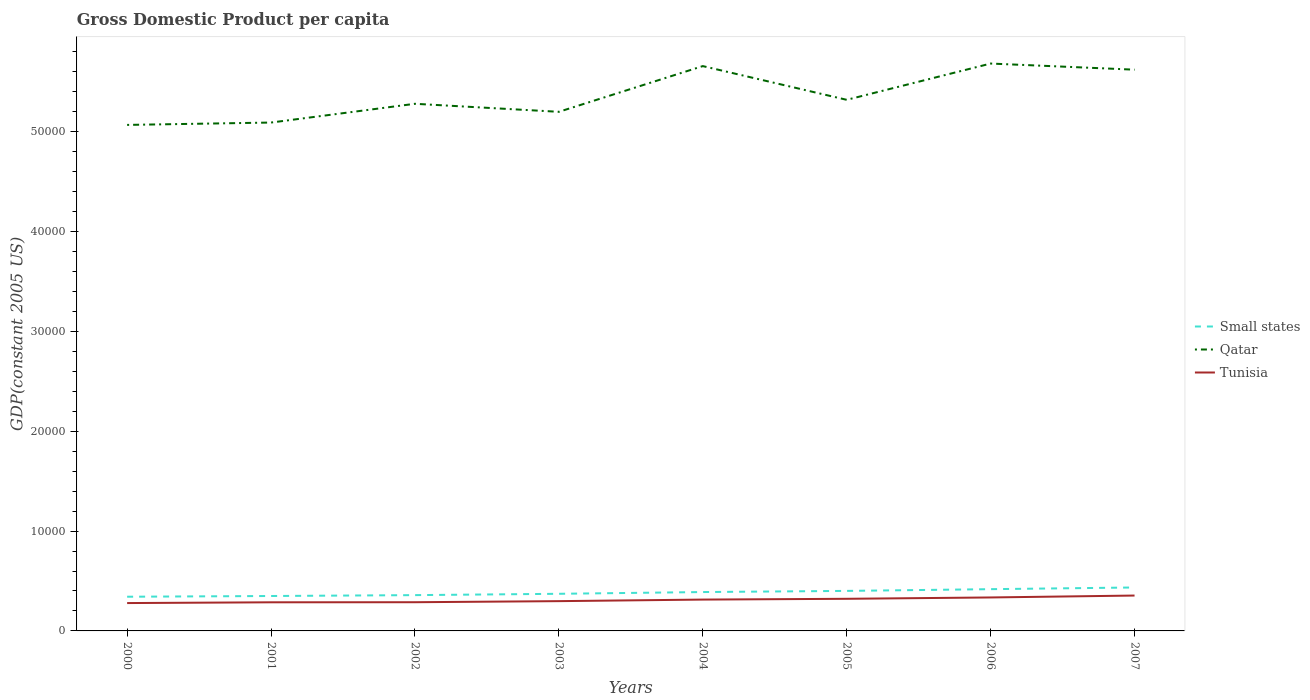Across all years, what is the maximum GDP per capita in Tunisia?
Ensure brevity in your answer.  2790.77. What is the total GDP per capita in Qatar in the graph?
Make the answer very short. -5655.65. What is the difference between the highest and the second highest GDP per capita in Tunisia?
Your answer should be compact. 753.89. How many lines are there?
Provide a succinct answer. 3. What is the difference between two consecutive major ticks on the Y-axis?
Your answer should be very brief. 10000. Are the values on the major ticks of Y-axis written in scientific E-notation?
Your answer should be very brief. No. Does the graph contain any zero values?
Provide a succinct answer. No. Does the graph contain grids?
Offer a very short reply. No. How are the legend labels stacked?
Provide a succinct answer. Vertical. What is the title of the graph?
Your response must be concise. Gross Domestic Product per capita. Does "Timor-Leste" appear as one of the legend labels in the graph?
Make the answer very short. No. What is the label or title of the Y-axis?
Provide a succinct answer. GDP(constant 2005 US). What is the GDP(constant 2005 US) in Small states in 2000?
Keep it short and to the point. 3425.97. What is the GDP(constant 2005 US) of Qatar in 2000?
Your answer should be compact. 5.07e+04. What is the GDP(constant 2005 US) in Tunisia in 2000?
Offer a terse response. 2790.77. What is the GDP(constant 2005 US) in Small states in 2001?
Your answer should be very brief. 3497.99. What is the GDP(constant 2005 US) in Qatar in 2001?
Your response must be concise. 5.09e+04. What is the GDP(constant 2005 US) in Tunisia in 2001?
Your answer should be very brief. 2867.26. What is the GDP(constant 2005 US) of Small states in 2002?
Your answer should be compact. 3586.27. What is the GDP(constant 2005 US) of Qatar in 2002?
Ensure brevity in your answer.  5.28e+04. What is the GDP(constant 2005 US) in Tunisia in 2002?
Your answer should be compact. 2875.89. What is the GDP(constant 2005 US) of Small states in 2003?
Offer a terse response. 3719.38. What is the GDP(constant 2005 US) of Qatar in 2003?
Make the answer very short. 5.20e+04. What is the GDP(constant 2005 US) of Tunisia in 2003?
Your answer should be very brief. 2983.31. What is the GDP(constant 2005 US) in Small states in 2004?
Offer a terse response. 3894.64. What is the GDP(constant 2005 US) of Qatar in 2004?
Offer a very short reply. 5.66e+04. What is the GDP(constant 2005 US) in Tunisia in 2004?
Provide a succinct answer. 3139.8. What is the GDP(constant 2005 US) of Small states in 2005?
Your answer should be very brief. 4009.71. What is the GDP(constant 2005 US) in Qatar in 2005?
Offer a very short reply. 5.32e+04. What is the GDP(constant 2005 US) in Tunisia in 2005?
Offer a terse response. 3217.97. What is the GDP(constant 2005 US) of Small states in 2006?
Offer a very short reply. 4182.88. What is the GDP(constant 2005 US) in Qatar in 2006?
Your response must be concise. 5.68e+04. What is the GDP(constant 2005 US) in Tunisia in 2006?
Give a very brief answer. 3353.65. What is the GDP(constant 2005 US) in Small states in 2007?
Keep it short and to the point. 4352.07. What is the GDP(constant 2005 US) of Qatar in 2007?
Your response must be concise. 5.62e+04. What is the GDP(constant 2005 US) in Tunisia in 2007?
Ensure brevity in your answer.  3544.65. Across all years, what is the maximum GDP(constant 2005 US) in Small states?
Your answer should be compact. 4352.07. Across all years, what is the maximum GDP(constant 2005 US) in Qatar?
Your answer should be compact. 5.68e+04. Across all years, what is the maximum GDP(constant 2005 US) in Tunisia?
Your answer should be very brief. 3544.65. Across all years, what is the minimum GDP(constant 2005 US) in Small states?
Make the answer very short. 3425.97. Across all years, what is the minimum GDP(constant 2005 US) of Qatar?
Provide a short and direct response. 5.07e+04. Across all years, what is the minimum GDP(constant 2005 US) of Tunisia?
Keep it short and to the point. 2790.77. What is the total GDP(constant 2005 US) in Small states in the graph?
Provide a short and direct response. 3.07e+04. What is the total GDP(constant 2005 US) of Qatar in the graph?
Provide a succinct answer. 4.29e+05. What is the total GDP(constant 2005 US) in Tunisia in the graph?
Your response must be concise. 2.48e+04. What is the difference between the GDP(constant 2005 US) in Small states in 2000 and that in 2001?
Offer a very short reply. -72.03. What is the difference between the GDP(constant 2005 US) of Qatar in 2000 and that in 2001?
Make the answer very short. -236.81. What is the difference between the GDP(constant 2005 US) of Tunisia in 2000 and that in 2001?
Provide a succinct answer. -76.5. What is the difference between the GDP(constant 2005 US) of Small states in 2000 and that in 2002?
Your response must be concise. -160.31. What is the difference between the GDP(constant 2005 US) in Qatar in 2000 and that in 2002?
Your response must be concise. -2116.26. What is the difference between the GDP(constant 2005 US) in Tunisia in 2000 and that in 2002?
Make the answer very short. -85.12. What is the difference between the GDP(constant 2005 US) in Small states in 2000 and that in 2003?
Your answer should be compact. -293.42. What is the difference between the GDP(constant 2005 US) in Qatar in 2000 and that in 2003?
Offer a terse response. -1311.81. What is the difference between the GDP(constant 2005 US) of Tunisia in 2000 and that in 2003?
Offer a terse response. -192.54. What is the difference between the GDP(constant 2005 US) of Small states in 2000 and that in 2004?
Make the answer very short. -468.68. What is the difference between the GDP(constant 2005 US) in Qatar in 2000 and that in 2004?
Your response must be concise. -5892.46. What is the difference between the GDP(constant 2005 US) in Tunisia in 2000 and that in 2004?
Provide a short and direct response. -349.03. What is the difference between the GDP(constant 2005 US) in Small states in 2000 and that in 2005?
Make the answer very short. -583.75. What is the difference between the GDP(constant 2005 US) in Qatar in 2000 and that in 2005?
Offer a terse response. -2513.63. What is the difference between the GDP(constant 2005 US) in Tunisia in 2000 and that in 2005?
Offer a terse response. -427.2. What is the difference between the GDP(constant 2005 US) of Small states in 2000 and that in 2006?
Offer a very short reply. -756.92. What is the difference between the GDP(constant 2005 US) in Qatar in 2000 and that in 2006?
Offer a terse response. -6147.15. What is the difference between the GDP(constant 2005 US) of Tunisia in 2000 and that in 2006?
Ensure brevity in your answer.  -562.89. What is the difference between the GDP(constant 2005 US) in Small states in 2000 and that in 2007?
Keep it short and to the point. -926.11. What is the difference between the GDP(constant 2005 US) of Qatar in 2000 and that in 2007?
Ensure brevity in your answer.  -5533.49. What is the difference between the GDP(constant 2005 US) of Tunisia in 2000 and that in 2007?
Offer a terse response. -753.89. What is the difference between the GDP(constant 2005 US) in Small states in 2001 and that in 2002?
Ensure brevity in your answer.  -88.28. What is the difference between the GDP(constant 2005 US) of Qatar in 2001 and that in 2002?
Your answer should be very brief. -1879.45. What is the difference between the GDP(constant 2005 US) of Tunisia in 2001 and that in 2002?
Ensure brevity in your answer.  -8.63. What is the difference between the GDP(constant 2005 US) in Small states in 2001 and that in 2003?
Provide a succinct answer. -221.39. What is the difference between the GDP(constant 2005 US) in Qatar in 2001 and that in 2003?
Ensure brevity in your answer.  -1075. What is the difference between the GDP(constant 2005 US) in Tunisia in 2001 and that in 2003?
Provide a succinct answer. -116.05. What is the difference between the GDP(constant 2005 US) of Small states in 2001 and that in 2004?
Your response must be concise. -396.65. What is the difference between the GDP(constant 2005 US) of Qatar in 2001 and that in 2004?
Your response must be concise. -5655.65. What is the difference between the GDP(constant 2005 US) in Tunisia in 2001 and that in 2004?
Your answer should be compact. -272.53. What is the difference between the GDP(constant 2005 US) of Small states in 2001 and that in 2005?
Your answer should be compact. -511.72. What is the difference between the GDP(constant 2005 US) in Qatar in 2001 and that in 2005?
Keep it short and to the point. -2276.82. What is the difference between the GDP(constant 2005 US) of Tunisia in 2001 and that in 2005?
Ensure brevity in your answer.  -350.71. What is the difference between the GDP(constant 2005 US) of Small states in 2001 and that in 2006?
Provide a succinct answer. -684.89. What is the difference between the GDP(constant 2005 US) in Qatar in 2001 and that in 2006?
Provide a short and direct response. -5910.35. What is the difference between the GDP(constant 2005 US) in Tunisia in 2001 and that in 2006?
Provide a succinct answer. -486.39. What is the difference between the GDP(constant 2005 US) in Small states in 2001 and that in 2007?
Your answer should be compact. -854.08. What is the difference between the GDP(constant 2005 US) of Qatar in 2001 and that in 2007?
Your answer should be very brief. -5296.69. What is the difference between the GDP(constant 2005 US) of Tunisia in 2001 and that in 2007?
Offer a very short reply. -677.39. What is the difference between the GDP(constant 2005 US) of Small states in 2002 and that in 2003?
Keep it short and to the point. -133.11. What is the difference between the GDP(constant 2005 US) of Qatar in 2002 and that in 2003?
Make the answer very short. 804.44. What is the difference between the GDP(constant 2005 US) in Tunisia in 2002 and that in 2003?
Offer a terse response. -107.42. What is the difference between the GDP(constant 2005 US) of Small states in 2002 and that in 2004?
Ensure brevity in your answer.  -308.37. What is the difference between the GDP(constant 2005 US) of Qatar in 2002 and that in 2004?
Your answer should be compact. -3776.21. What is the difference between the GDP(constant 2005 US) in Tunisia in 2002 and that in 2004?
Give a very brief answer. -263.9. What is the difference between the GDP(constant 2005 US) in Small states in 2002 and that in 2005?
Offer a terse response. -423.44. What is the difference between the GDP(constant 2005 US) of Qatar in 2002 and that in 2005?
Your answer should be very brief. -397.37. What is the difference between the GDP(constant 2005 US) of Tunisia in 2002 and that in 2005?
Your answer should be compact. -342.08. What is the difference between the GDP(constant 2005 US) in Small states in 2002 and that in 2006?
Give a very brief answer. -596.61. What is the difference between the GDP(constant 2005 US) of Qatar in 2002 and that in 2006?
Provide a short and direct response. -4030.9. What is the difference between the GDP(constant 2005 US) of Tunisia in 2002 and that in 2006?
Provide a succinct answer. -477.76. What is the difference between the GDP(constant 2005 US) in Small states in 2002 and that in 2007?
Make the answer very short. -765.8. What is the difference between the GDP(constant 2005 US) in Qatar in 2002 and that in 2007?
Your response must be concise. -3417.24. What is the difference between the GDP(constant 2005 US) in Tunisia in 2002 and that in 2007?
Give a very brief answer. -668.76. What is the difference between the GDP(constant 2005 US) of Small states in 2003 and that in 2004?
Ensure brevity in your answer.  -175.26. What is the difference between the GDP(constant 2005 US) of Qatar in 2003 and that in 2004?
Offer a terse response. -4580.65. What is the difference between the GDP(constant 2005 US) of Tunisia in 2003 and that in 2004?
Give a very brief answer. -156.49. What is the difference between the GDP(constant 2005 US) in Small states in 2003 and that in 2005?
Your answer should be compact. -290.33. What is the difference between the GDP(constant 2005 US) of Qatar in 2003 and that in 2005?
Offer a terse response. -1201.82. What is the difference between the GDP(constant 2005 US) of Tunisia in 2003 and that in 2005?
Keep it short and to the point. -234.66. What is the difference between the GDP(constant 2005 US) of Small states in 2003 and that in 2006?
Give a very brief answer. -463.5. What is the difference between the GDP(constant 2005 US) in Qatar in 2003 and that in 2006?
Your answer should be compact. -4835.34. What is the difference between the GDP(constant 2005 US) in Tunisia in 2003 and that in 2006?
Ensure brevity in your answer.  -370.34. What is the difference between the GDP(constant 2005 US) in Small states in 2003 and that in 2007?
Your answer should be compact. -632.69. What is the difference between the GDP(constant 2005 US) in Qatar in 2003 and that in 2007?
Ensure brevity in your answer.  -4221.68. What is the difference between the GDP(constant 2005 US) in Tunisia in 2003 and that in 2007?
Offer a very short reply. -561.34. What is the difference between the GDP(constant 2005 US) of Small states in 2004 and that in 2005?
Offer a very short reply. -115.07. What is the difference between the GDP(constant 2005 US) of Qatar in 2004 and that in 2005?
Provide a short and direct response. 3378.83. What is the difference between the GDP(constant 2005 US) in Tunisia in 2004 and that in 2005?
Offer a very short reply. -78.17. What is the difference between the GDP(constant 2005 US) of Small states in 2004 and that in 2006?
Your answer should be very brief. -288.24. What is the difference between the GDP(constant 2005 US) in Qatar in 2004 and that in 2006?
Offer a very short reply. -254.69. What is the difference between the GDP(constant 2005 US) of Tunisia in 2004 and that in 2006?
Your answer should be compact. -213.86. What is the difference between the GDP(constant 2005 US) in Small states in 2004 and that in 2007?
Your response must be concise. -457.43. What is the difference between the GDP(constant 2005 US) in Qatar in 2004 and that in 2007?
Keep it short and to the point. 358.97. What is the difference between the GDP(constant 2005 US) in Tunisia in 2004 and that in 2007?
Give a very brief answer. -404.86. What is the difference between the GDP(constant 2005 US) of Small states in 2005 and that in 2006?
Make the answer very short. -173.17. What is the difference between the GDP(constant 2005 US) of Qatar in 2005 and that in 2006?
Keep it short and to the point. -3633.53. What is the difference between the GDP(constant 2005 US) in Tunisia in 2005 and that in 2006?
Make the answer very short. -135.68. What is the difference between the GDP(constant 2005 US) in Small states in 2005 and that in 2007?
Your answer should be very brief. -342.36. What is the difference between the GDP(constant 2005 US) in Qatar in 2005 and that in 2007?
Keep it short and to the point. -3019.87. What is the difference between the GDP(constant 2005 US) of Tunisia in 2005 and that in 2007?
Your answer should be compact. -326.68. What is the difference between the GDP(constant 2005 US) in Small states in 2006 and that in 2007?
Offer a terse response. -169.19. What is the difference between the GDP(constant 2005 US) of Qatar in 2006 and that in 2007?
Your answer should be very brief. 613.66. What is the difference between the GDP(constant 2005 US) in Tunisia in 2006 and that in 2007?
Provide a short and direct response. -191. What is the difference between the GDP(constant 2005 US) of Small states in 2000 and the GDP(constant 2005 US) of Qatar in 2001?
Give a very brief answer. -4.75e+04. What is the difference between the GDP(constant 2005 US) in Small states in 2000 and the GDP(constant 2005 US) in Tunisia in 2001?
Give a very brief answer. 558.7. What is the difference between the GDP(constant 2005 US) of Qatar in 2000 and the GDP(constant 2005 US) of Tunisia in 2001?
Ensure brevity in your answer.  4.78e+04. What is the difference between the GDP(constant 2005 US) in Small states in 2000 and the GDP(constant 2005 US) in Qatar in 2002?
Offer a terse response. -4.94e+04. What is the difference between the GDP(constant 2005 US) of Small states in 2000 and the GDP(constant 2005 US) of Tunisia in 2002?
Make the answer very short. 550.07. What is the difference between the GDP(constant 2005 US) of Qatar in 2000 and the GDP(constant 2005 US) of Tunisia in 2002?
Your answer should be compact. 4.78e+04. What is the difference between the GDP(constant 2005 US) of Small states in 2000 and the GDP(constant 2005 US) of Qatar in 2003?
Your answer should be very brief. -4.86e+04. What is the difference between the GDP(constant 2005 US) in Small states in 2000 and the GDP(constant 2005 US) in Tunisia in 2003?
Ensure brevity in your answer.  442.65. What is the difference between the GDP(constant 2005 US) of Qatar in 2000 and the GDP(constant 2005 US) of Tunisia in 2003?
Make the answer very short. 4.77e+04. What is the difference between the GDP(constant 2005 US) of Small states in 2000 and the GDP(constant 2005 US) of Qatar in 2004?
Offer a terse response. -5.32e+04. What is the difference between the GDP(constant 2005 US) of Small states in 2000 and the GDP(constant 2005 US) of Tunisia in 2004?
Your answer should be very brief. 286.17. What is the difference between the GDP(constant 2005 US) in Qatar in 2000 and the GDP(constant 2005 US) in Tunisia in 2004?
Offer a very short reply. 4.76e+04. What is the difference between the GDP(constant 2005 US) of Small states in 2000 and the GDP(constant 2005 US) of Qatar in 2005?
Offer a terse response. -4.98e+04. What is the difference between the GDP(constant 2005 US) in Small states in 2000 and the GDP(constant 2005 US) in Tunisia in 2005?
Provide a succinct answer. 208. What is the difference between the GDP(constant 2005 US) in Qatar in 2000 and the GDP(constant 2005 US) in Tunisia in 2005?
Keep it short and to the point. 4.75e+04. What is the difference between the GDP(constant 2005 US) in Small states in 2000 and the GDP(constant 2005 US) in Qatar in 2006?
Your answer should be compact. -5.34e+04. What is the difference between the GDP(constant 2005 US) of Small states in 2000 and the GDP(constant 2005 US) of Tunisia in 2006?
Provide a succinct answer. 72.31. What is the difference between the GDP(constant 2005 US) of Qatar in 2000 and the GDP(constant 2005 US) of Tunisia in 2006?
Your answer should be compact. 4.73e+04. What is the difference between the GDP(constant 2005 US) in Small states in 2000 and the GDP(constant 2005 US) in Qatar in 2007?
Ensure brevity in your answer.  -5.28e+04. What is the difference between the GDP(constant 2005 US) in Small states in 2000 and the GDP(constant 2005 US) in Tunisia in 2007?
Your answer should be very brief. -118.69. What is the difference between the GDP(constant 2005 US) in Qatar in 2000 and the GDP(constant 2005 US) in Tunisia in 2007?
Provide a short and direct response. 4.71e+04. What is the difference between the GDP(constant 2005 US) in Small states in 2001 and the GDP(constant 2005 US) in Qatar in 2002?
Offer a terse response. -4.93e+04. What is the difference between the GDP(constant 2005 US) in Small states in 2001 and the GDP(constant 2005 US) in Tunisia in 2002?
Offer a very short reply. 622.1. What is the difference between the GDP(constant 2005 US) of Qatar in 2001 and the GDP(constant 2005 US) of Tunisia in 2002?
Ensure brevity in your answer.  4.81e+04. What is the difference between the GDP(constant 2005 US) in Small states in 2001 and the GDP(constant 2005 US) in Qatar in 2003?
Provide a succinct answer. -4.85e+04. What is the difference between the GDP(constant 2005 US) in Small states in 2001 and the GDP(constant 2005 US) in Tunisia in 2003?
Make the answer very short. 514.68. What is the difference between the GDP(constant 2005 US) in Qatar in 2001 and the GDP(constant 2005 US) in Tunisia in 2003?
Offer a very short reply. 4.79e+04. What is the difference between the GDP(constant 2005 US) of Small states in 2001 and the GDP(constant 2005 US) of Qatar in 2004?
Give a very brief answer. -5.31e+04. What is the difference between the GDP(constant 2005 US) in Small states in 2001 and the GDP(constant 2005 US) in Tunisia in 2004?
Keep it short and to the point. 358.2. What is the difference between the GDP(constant 2005 US) in Qatar in 2001 and the GDP(constant 2005 US) in Tunisia in 2004?
Offer a very short reply. 4.78e+04. What is the difference between the GDP(constant 2005 US) in Small states in 2001 and the GDP(constant 2005 US) in Qatar in 2005?
Ensure brevity in your answer.  -4.97e+04. What is the difference between the GDP(constant 2005 US) of Small states in 2001 and the GDP(constant 2005 US) of Tunisia in 2005?
Make the answer very short. 280.03. What is the difference between the GDP(constant 2005 US) in Qatar in 2001 and the GDP(constant 2005 US) in Tunisia in 2005?
Make the answer very short. 4.77e+04. What is the difference between the GDP(constant 2005 US) of Small states in 2001 and the GDP(constant 2005 US) of Qatar in 2006?
Your response must be concise. -5.33e+04. What is the difference between the GDP(constant 2005 US) in Small states in 2001 and the GDP(constant 2005 US) in Tunisia in 2006?
Provide a succinct answer. 144.34. What is the difference between the GDP(constant 2005 US) in Qatar in 2001 and the GDP(constant 2005 US) in Tunisia in 2006?
Your answer should be very brief. 4.76e+04. What is the difference between the GDP(constant 2005 US) in Small states in 2001 and the GDP(constant 2005 US) in Qatar in 2007?
Offer a terse response. -5.27e+04. What is the difference between the GDP(constant 2005 US) of Small states in 2001 and the GDP(constant 2005 US) of Tunisia in 2007?
Your answer should be compact. -46.66. What is the difference between the GDP(constant 2005 US) in Qatar in 2001 and the GDP(constant 2005 US) in Tunisia in 2007?
Your answer should be compact. 4.74e+04. What is the difference between the GDP(constant 2005 US) of Small states in 2002 and the GDP(constant 2005 US) of Qatar in 2003?
Your response must be concise. -4.84e+04. What is the difference between the GDP(constant 2005 US) in Small states in 2002 and the GDP(constant 2005 US) in Tunisia in 2003?
Make the answer very short. 602.96. What is the difference between the GDP(constant 2005 US) in Qatar in 2002 and the GDP(constant 2005 US) in Tunisia in 2003?
Your answer should be very brief. 4.98e+04. What is the difference between the GDP(constant 2005 US) of Small states in 2002 and the GDP(constant 2005 US) of Qatar in 2004?
Provide a succinct answer. -5.30e+04. What is the difference between the GDP(constant 2005 US) of Small states in 2002 and the GDP(constant 2005 US) of Tunisia in 2004?
Make the answer very short. 446.48. What is the difference between the GDP(constant 2005 US) in Qatar in 2002 and the GDP(constant 2005 US) in Tunisia in 2004?
Provide a succinct answer. 4.97e+04. What is the difference between the GDP(constant 2005 US) of Small states in 2002 and the GDP(constant 2005 US) of Qatar in 2005?
Provide a succinct answer. -4.96e+04. What is the difference between the GDP(constant 2005 US) in Small states in 2002 and the GDP(constant 2005 US) in Tunisia in 2005?
Your answer should be compact. 368.3. What is the difference between the GDP(constant 2005 US) in Qatar in 2002 and the GDP(constant 2005 US) in Tunisia in 2005?
Your response must be concise. 4.96e+04. What is the difference between the GDP(constant 2005 US) in Small states in 2002 and the GDP(constant 2005 US) in Qatar in 2006?
Give a very brief answer. -5.33e+04. What is the difference between the GDP(constant 2005 US) of Small states in 2002 and the GDP(constant 2005 US) of Tunisia in 2006?
Your response must be concise. 232.62. What is the difference between the GDP(constant 2005 US) in Qatar in 2002 and the GDP(constant 2005 US) in Tunisia in 2006?
Your response must be concise. 4.95e+04. What is the difference between the GDP(constant 2005 US) of Small states in 2002 and the GDP(constant 2005 US) of Qatar in 2007?
Ensure brevity in your answer.  -5.26e+04. What is the difference between the GDP(constant 2005 US) in Small states in 2002 and the GDP(constant 2005 US) in Tunisia in 2007?
Keep it short and to the point. 41.62. What is the difference between the GDP(constant 2005 US) in Qatar in 2002 and the GDP(constant 2005 US) in Tunisia in 2007?
Provide a succinct answer. 4.93e+04. What is the difference between the GDP(constant 2005 US) in Small states in 2003 and the GDP(constant 2005 US) in Qatar in 2004?
Your answer should be very brief. -5.29e+04. What is the difference between the GDP(constant 2005 US) in Small states in 2003 and the GDP(constant 2005 US) in Tunisia in 2004?
Give a very brief answer. 579.59. What is the difference between the GDP(constant 2005 US) of Qatar in 2003 and the GDP(constant 2005 US) of Tunisia in 2004?
Your answer should be compact. 4.89e+04. What is the difference between the GDP(constant 2005 US) of Small states in 2003 and the GDP(constant 2005 US) of Qatar in 2005?
Ensure brevity in your answer.  -4.95e+04. What is the difference between the GDP(constant 2005 US) in Small states in 2003 and the GDP(constant 2005 US) in Tunisia in 2005?
Make the answer very short. 501.41. What is the difference between the GDP(constant 2005 US) in Qatar in 2003 and the GDP(constant 2005 US) in Tunisia in 2005?
Make the answer very short. 4.88e+04. What is the difference between the GDP(constant 2005 US) of Small states in 2003 and the GDP(constant 2005 US) of Qatar in 2006?
Your response must be concise. -5.31e+04. What is the difference between the GDP(constant 2005 US) of Small states in 2003 and the GDP(constant 2005 US) of Tunisia in 2006?
Your answer should be very brief. 365.73. What is the difference between the GDP(constant 2005 US) of Qatar in 2003 and the GDP(constant 2005 US) of Tunisia in 2006?
Your answer should be very brief. 4.87e+04. What is the difference between the GDP(constant 2005 US) of Small states in 2003 and the GDP(constant 2005 US) of Qatar in 2007?
Make the answer very short. -5.25e+04. What is the difference between the GDP(constant 2005 US) in Small states in 2003 and the GDP(constant 2005 US) in Tunisia in 2007?
Provide a short and direct response. 174.73. What is the difference between the GDP(constant 2005 US) of Qatar in 2003 and the GDP(constant 2005 US) of Tunisia in 2007?
Your response must be concise. 4.85e+04. What is the difference between the GDP(constant 2005 US) in Small states in 2004 and the GDP(constant 2005 US) in Qatar in 2005?
Your answer should be compact. -4.93e+04. What is the difference between the GDP(constant 2005 US) in Small states in 2004 and the GDP(constant 2005 US) in Tunisia in 2005?
Make the answer very short. 676.68. What is the difference between the GDP(constant 2005 US) of Qatar in 2004 and the GDP(constant 2005 US) of Tunisia in 2005?
Make the answer very short. 5.34e+04. What is the difference between the GDP(constant 2005 US) in Small states in 2004 and the GDP(constant 2005 US) in Qatar in 2006?
Make the answer very short. -5.29e+04. What is the difference between the GDP(constant 2005 US) of Small states in 2004 and the GDP(constant 2005 US) of Tunisia in 2006?
Give a very brief answer. 540.99. What is the difference between the GDP(constant 2005 US) in Qatar in 2004 and the GDP(constant 2005 US) in Tunisia in 2006?
Make the answer very short. 5.32e+04. What is the difference between the GDP(constant 2005 US) of Small states in 2004 and the GDP(constant 2005 US) of Qatar in 2007?
Offer a terse response. -5.23e+04. What is the difference between the GDP(constant 2005 US) in Small states in 2004 and the GDP(constant 2005 US) in Tunisia in 2007?
Offer a very short reply. 349.99. What is the difference between the GDP(constant 2005 US) of Qatar in 2004 and the GDP(constant 2005 US) of Tunisia in 2007?
Your answer should be very brief. 5.30e+04. What is the difference between the GDP(constant 2005 US) in Small states in 2005 and the GDP(constant 2005 US) in Qatar in 2006?
Make the answer very short. -5.28e+04. What is the difference between the GDP(constant 2005 US) in Small states in 2005 and the GDP(constant 2005 US) in Tunisia in 2006?
Provide a short and direct response. 656.06. What is the difference between the GDP(constant 2005 US) of Qatar in 2005 and the GDP(constant 2005 US) of Tunisia in 2006?
Provide a succinct answer. 4.99e+04. What is the difference between the GDP(constant 2005 US) in Small states in 2005 and the GDP(constant 2005 US) in Qatar in 2007?
Provide a succinct answer. -5.22e+04. What is the difference between the GDP(constant 2005 US) of Small states in 2005 and the GDP(constant 2005 US) of Tunisia in 2007?
Give a very brief answer. 465.06. What is the difference between the GDP(constant 2005 US) in Qatar in 2005 and the GDP(constant 2005 US) in Tunisia in 2007?
Give a very brief answer. 4.97e+04. What is the difference between the GDP(constant 2005 US) in Small states in 2006 and the GDP(constant 2005 US) in Qatar in 2007?
Give a very brief answer. -5.20e+04. What is the difference between the GDP(constant 2005 US) of Small states in 2006 and the GDP(constant 2005 US) of Tunisia in 2007?
Give a very brief answer. 638.23. What is the difference between the GDP(constant 2005 US) of Qatar in 2006 and the GDP(constant 2005 US) of Tunisia in 2007?
Keep it short and to the point. 5.33e+04. What is the average GDP(constant 2005 US) of Small states per year?
Offer a very short reply. 3833.62. What is the average GDP(constant 2005 US) in Qatar per year?
Make the answer very short. 5.37e+04. What is the average GDP(constant 2005 US) of Tunisia per year?
Make the answer very short. 3096.66. In the year 2000, what is the difference between the GDP(constant 2005 US) of Small states and GDP(constant 2005 US) of Qatar?
Offer a terse response. -4.73e+04. In the year 2000, what is the difference between the GDP(constant 2005 US) in Small states and GDP(constant 2005 US) in Tunisia?
Provide a short and direct response. 635.2. In the year 2000, what is the difference between the GDP(constant 2005 US) in Qatar and GDP(constant 2005 US) in Tunisia?
Give a very brief answer. 4.79e+04. In the year 2001, what is the difference between the GDP(constant 2005 US) in Small states and GDP(constant 2005 US) in Qatar?
Your answer should be very brief. -4.74e+04. In the year 2001, what is the difference between the GDP(constant 2005 US) of Small states and GDP(constant 2005 US) of Tunisia?
Offer a terse response. 630.73. In the year 2001, what is the difference between the GDP(constant 2005 US) of Qatar and GDP(constant 2005 US) of Tunisia?
Your response must be concise. 4.81e+04. In the year 2002, what is the difference between the GDP(constant 2005 US) in Small states and GDP(constant 2005 US) in Qatar?
Give a very brief answer. -4.92e+04. In the year 2002, what is the difference between the GDP(constant 2005 US) of Small states and GDP(constant 2005 US) of Tunisia?
Offer a terse response. 710.38. In the year 2002, what is the difference between the GDP(constant 2005 US) in Qatar and GDP(constant 2005 US) in Tunisia?
Your response must be concise. 4.99e+04. In the year 2003, what is the difference between the GDP(constant 2005 US) of Small states and GDP(constant 2005 US) of Qatar?
Your answer should be compact. -4.83e+04. In the year 2003, what is the difference between the GDP(constant 2005 US) of Small states and GDP(constant 2005 US) of Tunisia?
Ensure brevity in your answer.  736.07. In the year 2003, what is the difference between the GDP(constant 2005 US) of Qatar and GDP(constant 2005 US) of Tunisia?
Offer a very short reply. 4.90e+04. In the year 2004, what is the difference between the GDP(constant 2005 US) in Small states and GDP(constant 2005 US) in Qatar?
Offer a very short reply. -5.27e+04. In the year 2004, what is the difference between the GDP(constant 2005 US) in Small states and GDP(constant 2005 US) in Tunisia?
Offer a very short reply. 754.85. In the year 2004, what is the difference between the GDP(constant 2005 US) of Qatar and GDP(constant 2005 US) of Tunisia?
Provide a short and direct response. 5.34e+04. In the year 2005, what is the difference between the GDP(constant 2005 US) of Small states and GDP(constant 2005 US) of Qatar?
Provide a succinct answer. -4.92e+04. In the year 2005, what is the difference between the GDP(constant 2005 US) of Small states and GDP(constant 2005 US) of Tunisia?
Offer a very short reply. 791.75. In the year 2005, what is the difference between the GDP(constant 2005 US) of Qatar and GDP(constant 2005 US) of Tunisia?
Offer a terse response. 5.00e+04. In the year 2006, what is the difference between the GDP(constant 2005 US) in Small states and GDP(constant 2005 US) in Qatar?
Ensure brevity in your answer.  -5.27e+04. In the year 2006, what is the difference between the GDP(constant 2005 US) in Small states and GDP(constant 2005 US) in Tunisia?
Give a very brief answer. 829.23. In the year 2006, what is the difference between the GDP(constant 2005 US) of Qatar and GDP(constant 2005 US) of Tunisia?
Your response must be concise. 5.35e+04. In the year 2007, what is the difference between the GDP(constant 2005 US) of Small states and GDP(constant 2005 US) of Qatar?
Provide a short and direct response. -5.19e+04. In the year 2007, what is the difference between the GDP(constant 2005 US) of Small states and GDP(constant 2005 US) of Tunisia?
Make the answer very short. 807.42. In the year 2007, what is the difference between the GDP(constant 2005 US) in Qatar and GDP(constant 2005 US) in Tunisia?
Keep it short and to the point. 5.27e+04. What is the ratio of the GDP(constant 2005 US) in Small states in 2000 to that in 2001?
Provide a short and direct response. 0.98. What is the ratio of the GDP(constant 2005 US) of Tunisia in 2000 to that in 2001?
Give a very brief answer. 0.97. What is the ratio of the GDP(constant 2005 US) in Small states in 2000 to that in 2002?
Provide a succinct answer. 0.96. What is the ratio of the GDP(constant 2005 US) of Qatar in 2000 to that in 2002?
Keep it short and to the point. 0.96. What is the ratio of the GDP(constant 2005 US) in Tunisia in 2000 to that in 2002?
Your response must be concise. 0.97. What is the ratio of the GDP(constant 2005 US) in Small states in 2000 to that in 2003?
Offer a terse response. 0.92. What is the ratio of the GDP(constant 2005 US) in Qatar in 2000 to that in 2003?
Give a very brief answer. 0.97. What is the ratio of the GDP(constant 2005 US) of Tunisia in 2000 to that in 2003?
Your response must be concise. 0.94. What is the ratio of the GDP(constant 2005 US) in Small states in 2000 to that in 2004?
Offer a very short reply. 0.88. What is the ratio of the GDP(constant 2005 US) in Qatar in 2000 to that in 2004?
Your answer should be compact. 0.9. What is the ratio of the GDP(constant 2005 US) in Tunisia in 2000 to that in 2004?
Offer a terse response. 0.89. What is the ratio of the GDP(constant 2005 US) in Small states in 2000 to that in 2005?
Your answer should be compact. 0.85. What is the ratio of the GDP(constant 2005 US) of Qatar in 2000 to that in 2005?
Keep it short and to the point. 0.95. What is the ratio of the GDP(constant 2005 US) of Tunisia in 2000 to that in 2005?
Make the answer very short. 0.87. What is the ratio of the GDP(constant 2005 US) in Small states in 2000 to that in 2006?
Ensure brevity in your answer.  0.82. What is the ratio of the GDP(constant 2005 US) in Qatar in 2000 to that in 2006?
Ensure brevity in your answer.  0.89. What is the ratio of the GDP(constant 2005 US) in Tunisia in 2000 to that in 2006?
Ensure brevity in your answer.  0.83. What is the ratio of the GDP(constant 2005 US) in Small states in 2000 to that in 2007?
Offer a terse response. 0.79. What is the ratio of the GDP(constant 2005 US) of Qatar in 2000 to that in 2007?
Keep it short and to the point. 0.9. What is the ratio of the GDP(constant 2005 US) of Tunisia in 2000 to that in 2007?
Keep it short and to the point. 0.79. What is the ratio of the GDP(constant 2005 US) in Small states in 2001 to that in 2002?
Give a very brief answer. 0.98. What is the ratio of the GDP(constant 2005 US) of Qatar in 2001 to that in 2002?
Keep it short and to the point. 0.96. What is the ratio of the GDP(constant 2005 US) in Small states in 2001 to that in 2003?
Your response must be concise. 0.94. What is the ratio of the GDP(constant 2005 US) in Qatar in 2001 to that in 2003?
Your response must be concise. 0.98. What is the ratio of the GDP(constant 2005 US) of Tunisia in 2001 to that in 2003?
Offer a very short reply. 0.96. What is the ratio of the GDP(constant 2005 US) of Small states in 2001 to that in 2004?
Keep it short and to the point. 0.9. What is the ratio of the GDP(constant 2005 US) in Qatar in 2001 to that in 2004?
Offer a terse response. 0.9. What is the ratio of the GDP(constant 2005 US) of Tunisia in 2001 to that in 2004?
Give a very brief answer. 0.91. What is the ratio of the GDP(constant 2005 US) of Small states in 2001 to that in 2005?
Provide a short and direct response. 0.87. What is the ratio of the GDP(constant 2005 US) in Qatar in 2001 to that in 2005?
Offer a terse response. 0.96. What is the ratio of the GDP(constant 2005 US) in Tunisia in 2001 to that in 2005?
Ensure brevity in your answer.  0.89. What is the ratio of the GDP(constant 2005 US) in Small states in 2001 to that in 2006?
Provide a succinct answer. 0.84. What is the ratio of the GDP(constant 2005 US) of Qatar in 2001 to that in 2006?
Keep it short and to the point. 0.9. What is the ratio of the GDP(constant 2005 US) in Tunisia in 2001 to that in 2006?
Provide a succinct answer. 0.85. What is the ratio of the GDP(constant 2005 US) of Small states in 2001 to that in 2007?
Give a very brief answer. 0.8. What is the ratio of the GDP(constant 2005 US) in Qatar in 2001 to that in 2007?
Ensure brevity in your answer.  0.91. What is the ratio of the GDP(constant 2005 US) of Tunisia in 2001 to that in 2007?
Your answer should be compact. 0.81. What is the ratio of the GDP(constant 2005 US) of Small states in 2002 to that in 2003?
Offer a terse response. 0.96. What is the ratio of the GDP(constant 2005 US) of Qatar in 2002 to that in 2003?
Offer a terse response. 1.02. What is the ratio of the GDP(constant 2005 US) of Small states in 2002 to that in 2004?
Provide a short and direct response. 0.92. What is the ratio of the GDP(constant 2005 US) of Tunisia in 2002 to that in 2004?
Offer a very short reply. 0.92. What is the ratio of the GDP(constant 2005 US) of Small states in 2002 to that in 2005?
Ensure brevity in your answer.  0.89. What is the ratio of the GDP(constant 2005 US) in Qatar in 2002 to that in 2005?
Provide a succinct answer. 0.99. What is the ratio of the GDP(constant 2005 US) of Tunisia in 2002 to that in 2005?
Ensure brevity in your answer.  0.89. What is the ratio of the GDP(constant 2005 US) of Small states in 2002 to that in 2006?
Offer a very short reply. 0.86. What is the ratio of the GDP(constant 2005 US) of Qatar in 2002 to that in 2006?
Offer a terse response. 0.93. What is the ratio of the GDP(constant 2005 US) in Tunisia in 2002 to that in 2006?
Make the answer very short. 0.86. What is the ratio of the GDP(constant 2005 US) in Small states in 2002 to that in 2007?
Make the answer very short. 0.82. What is the ratio of the GDP(constant 2005 US) of Qatar in 2002 to that in 2007?
Provide a short and direct response. 0.94. What is the ratio of the GDP(constant 2005 US) of Tunisia in 2002 to that in 2007?
Offer a terse response. 0.81. What is the ratio of the GDP(constant 2005 US) of Small states in 2003 to that in 2004?
Your answer should be compact. 0.95. What is the ratio of the GDP(constant 2005 US) of Qatar in 2003 to that in 2004?
Ensure brevity in your answer.  0.92. What is the ratio of the GDP(constant 2005 US) in Tunisia in 2003 to that in 2004?
Offer a very short reply. 0.95. What is the ratio of the GDP(constant 2005 US) of Small states in 2003 to that in 2005?
Provide a succinct answer. 0.93. What is the ratio of the GDP(constant 2005 US) in Qatar in 2003 to that in 2005?
Your answer should be very brief. 0.98. What is the ratio of the GDP(constant 2005 US) of Tunisia in 2003 to that in 2005?
Your answer should be very brief. 0.93. What is the ratio of the GDP(constant 2005 US) of Small states in 2003 to that in 2006?
Provide a succinct answer. 0.89. What is the ratio of the GDP(constant 2005 US) of Qatar in 2003 to that in 2006?
Make the answer very short. 0.91. What is the ratio of the GDP(constant 2005 US) of Tunisia in 2003 to that in 2006?
Ensure brevity in your answer.  0.89. What is the ratio of the GDP(constant 2005 US) in Small states in 2003 to that in 2007?
Your answer should be compact. 0.85. What is the ratio of the GDP(constant 2005 US) in Qatar in 2003 to that in 2007?
Your response must be concise. 0.92. What is the ratio of the GDP(constant 2005 US) of Tunisia in 2003 to that in 2007?
Offer a terse response. 0.84. What is the ratio of the GDP(constant 2005 US) of Small states in 2004 to that in 2005?
Provide a short and direct response. 0.97. What is the ratio of the GDP(constant 2005 US) in Qatar in 2004 to that in 2005?
Ensure brevity in your answer.  1.06. What is the ratio of the GDP(constant 2005 US) of Tunisia in 2004 to that in 2005?
Provide a short and direct response. 0.98. What is the ratio of the GDP(constant 2005 US) in Small states in 2004 to that in 2006?
Your answer should be compact. 0.93. What is the ratio of the GDP(constant 2005 US) in Qatar in 2004 to that in 2006?
Your answer should be very brief. 1. What is the ratio of the GDP(constant 2005 US) in Tunisia in 2004 to that in 2006?
Your answer should be very brief. 0.94. What is the ratio of the GDP(constant 2005 US) in Small states in 2004 to that in 2007?
Keep it short and to the point. 0.89. What is the ratio of the GDP(constant 2005 US) of Qatar in 2004 to that in 2007?
Keep it short and to the point. 1.01. What is the ratio of the GDP(constant 2005 US) of Tunisia in 2004 to that in 2007?
Offer a terse response. 0.89. What is the ratio of the GDP(constant 2005 US) of Small states in 2005 to that in 2006?
Make the answer very short. 0.96. What is the ratio of the GDP(constant 2005 US) in Qatar in 2005 to that in 2006?
Make the answer very short. 0.94. What is the ratio of the GDP(constant 2005 US) of Tunisia in 2005 to that in 2006?
Your answer should be very brief. 0.96. What is the ratio of the GDP(constant 2005 US) of Small states in 2005 to that in 2007?
Give a very brief answer. 0.92. What is the ratio of the GDP(constant 2005 US) of Qatar in 2005 to that in 2007?
Your answer should be very brief. 0.95. What is the ratio of the GDP(constant 2005 US) in Tunisia in 2005 to that in 2007?
Your response must be concise. 0.91. What is the ratio of the GDP(constant 2005 US) of Small states in 2006 to that in 2007?
Provide a short and direct response. 0.96. What is the ratio of the GDP(constant 2005 US) in Qatar in 2006 to that in 2007?
Provide a succinct answer. 1.01. What is the ratio of the GDP(constant 2005 US) in Tunisia in 2006 to that in 2007?
Your answer should be very brief. 0.95. What is the difference between the highest and the second highest GDP(constant 2005 US) in Small states?
Make the answer very short. 169.19. What is the difference between the highest and the second highest GDP(constant 2005 US) of Qatar?
Give a very brief answer. 254.69. What is the difference between the highest and the second highest GDP(constant 2005 US) in Tunisia?
Give a very brief answer. 191. What is the difference between the highest and the lowest GDP(constant 2005 US) of Small states?
Offer a very short reply. 926.11. What is the difference between the highest and the lowest GDP(constant 2005 US) in Qatar?
Your answer should be very brief. 6147.15. What is the difference between the highest and the lowest GDP(constant 2005 US) in Tunisia?
Give a very brief answer. 753.89. 